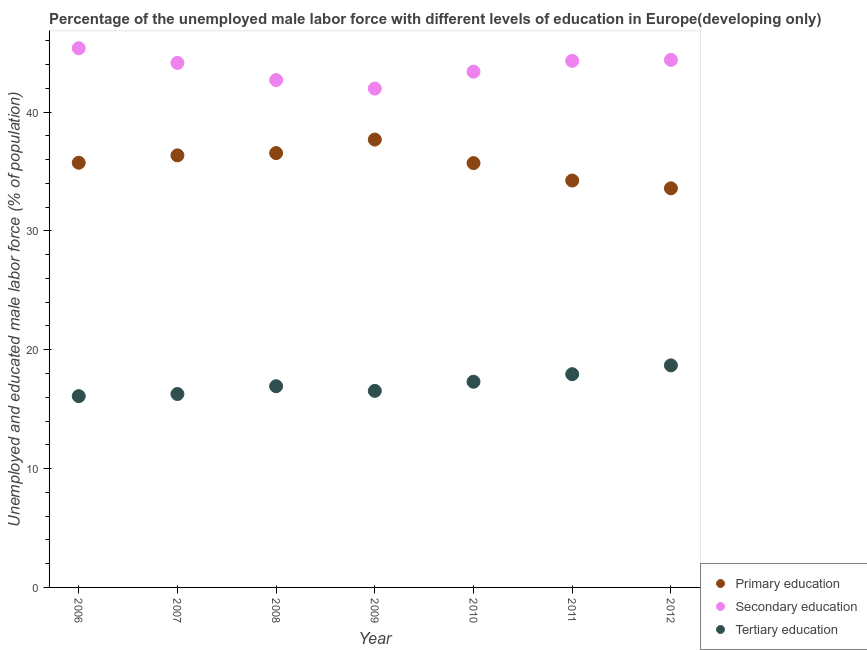Is the number of dotlines equal to the number of legend labels?
Provide a short and direct response. Yes. What is the percentage of male labor force who received primary education in 2007?
Your answer should be very brief. 36.36. Across all years, what is the maximum percentage of male labor force who received primary education?
Your response must be concise. 37.68. Across all years, what is the minimum percentage of male labor force who received secondary education?
Provide a short and direct response. 41.97. What is the total percentage of male labor force who received tertiary education in the graph?
Your answer should be very brief. 119.77. What is the difference between the percentage of male labor force who received primary education in 2011 and that in 2012?
Keep it short and to the point. 0.66. What is the difference between the percentage of male labor force who received tertiary education in 2007 and the percentage of male labor force who received secondary education in 2009?
Offer a very short reply. -25.7. What is the average percentage of male labor force who received secondary education per year?
Your answer should be compact. 43.75. In the year 2009, what is the difference between the percentage of male labor force who received tertiary education and percentage of male labor force who received secondary education?
Your answer should be compact. -25.44. What is the ratio of the percentage of male labor force who received secondary education in 2009 to that in 2010?
Keep it short and to the point. 0.97. What is the difference between the highest and the second highest percentage of male labor force who received secondary education?
Your answer should be compact. 0.98. What is the difference between the highest and the lowest percentage of male labor force who received secondary education?
Offer a terse response. 3.4. Is the percentage of male labor force who received primary education strictly greater than the percentage of male labor force who received tertiary education over the years?
Your answer should be compact. Yes. Are the values on the major ticks of Y-axis written in scientific E-notation?
Make the answer very short. No. Does the graph contain grids?
Keep it short and to the point. No. Where does the legend appear in the graph?
Your answer should be compact. Bottom right. How are the legend labels stacked?
Your answer should be compact. Vertical. What is the title of the graph?
Ensure brevity in your answer.  Percentage of the unemployed male labor force with different levels of education in Europe(developing only). Does "Ages 50+" appear as one of the legend labels in the graph?
Provide a short and direct response. No. What is the label or title of the Y-axis?
Your answer should be compact. Unemployed and educated male labor force (% of population). What is the Unemployed and educated male labor force (% of population) in Primary education in 2006?
Keep it short and to the point. 35.73. What is the Unemployed and educated male labor force (% of population) of Secondary education in 2006?
Offer a terse response. 45.37. What is the Unemployed and educated male labor force (% of population) of Tertiary education in 2006?
Offer a very short reply. 16.1. What is the Unemployed and educated male labor force (% of population) in Primary education in 2007?
Keep it short and to the point. 36.36. What is the Unemployed and educated male labor force (% of population) in Secondary education in 2007?
Your response must be concise. 44.13. What is the Unemployed and educated male labor force (% of population) of Tertiary education in 2007?
Your answer should be compact. 16.27. What is the Unemployed and educated male labor force (% of population) in Primary education in 2008?
Offer a very short reply. 36.55. What is the Unemployed and educated male labor force (% of population) in Secondary education in 2008?
Your answer should be compact. 42.69. What is the Unemployed and educated male labor force (% of population) of Tertiary education in 2008?
Provide a succinct answer. 16.93. What is the Unemployed and educated male labor force (% of population) in Primary education in 2009?
Your response must be concise. 37.68. What is the Unemployed and educated male labor force (% of population) of Secondary education in 2009?
Give a very brief answer. 41.97. What is the Unemployed and educated male labor force (% of population) in Tertiary education in 2009?
Give a very brief answer. 16.54. What is the Unemployed and educated male labor force (% of population) of Primary education in 2010?
Offer a terse response. 35.7. What is the Unemployed and educated male labor force (% of population) of Secondary education in 2010?
Offer a very short reply. 43.39. What is the Unemployed and educated male labor force (% of population) of Tertiary education in 2010?
Provide a succinct answer. 17.31. What is the Unemployed and educated male labor force (% of population) in Primary education in 2011?
Your response must be concise. 34.24. What is the Unemployed and educated male labor force (% of population) of Secondary education in 2011?
Make the answer very short. 44.31. What is the Unemployed and educated male labor force (% of population) of Tertiary education in 2011?
Your response must be concise. 17.94. What is the Unemployed and educated male labor force (% of population) in Primary education in 2012?
Ensure brevity in your answer.  33.58. What is the Unemployed and educated male labor force (% of population) in Secondary education in 2012?
Keep it short and to the point. 44.39. What is the Unemployed and educated male labor force (% of population) in Tertiary education in 2012?
Provide a short and direct response. 18.68. Across all years, what is the maximum Unemployed and educated male labor force (% of population) of Primary education?
Ensure brevity in your answer.  37.68. Across all years, what is the maximum Unemployed and educated male labor force (% of population) of Secondary education?
Make the answer very short. 45.37. Across all years, what is the maximum Unemployed and educated male labor force (% of population) in Tertiary education?
Ensure brevity in your answer.  18.68. Across all years, what is the minimum Unemployed and educated male labor force (% of population) in Primary education?
Your answer should be compact. 33.58. Across all years, what is the minimum Unemployed and educated male labor force (% of population) in Secondary education?
Provide a succinct answer. 41.97. Across all years, what is the minimum Unemployed and educated male labor force (% of population) of Tertiary education?
Offer a terse response. 16.1. What is the total Unemployed and educated male labor force (% of population) in Primary education in the graph?
Your answer should be very brief. 249.84. What is the total Unemployed and educated male labor force (% of population) of Secondary education in the graph?
Give a very brief answer. 306.25. What is the total Unemployed and educated male labor force (% of population) of Tertiary education in the graph?
Your response must be concise. 119.77. What is the difference between the Unemployed and educated male labor force (% of population) of Primary education in 2006 and that in 2007?
Make the answer very short. -0.62. What is the difference between the Unemployed and educated male labor force (% of population) in Secondary education in 2006 and that in 2007?
Your response must be concise. 1.24. What is the difference between the Unemployed and educated male labor force (% of population) in Tertiary education in 2006 and that in 2007?
Offer a terse response. -0.18. What is the difference between the Unemployed and educated male labor force (% of population) of Primary education in 2006 and that in 2008?
Provide a short and direct response. -0.81. What is the difference between the Unemployed and educated male labor force (% of population) in Secondary education in 2006 and that in 2008?
Your answer should be very brief. 2.68. What is the difference between the Unemployed and educated male labor force (% of population) in Tertiary education in 2006 and that in 2008?
Your response must be concise. -0.83. What is the difference between the Unemployed and educated male labor force (% of population) of Primary education in 2006 and that in 2009?
Your answer should be very brief. -1.95. What is the difference between the Unemployed and educated male labor force (% of population) in Secondary education in 2006 and that in 2009?
Ensure brevity in your answer.  3.4. What is the difference between the Unemployed and educated male labor force (% of population) of Tertiary education in 2006 and that in 2009?
Your response must be concise. -0.44. What is the difference between the Unemployed and educated male labor force (% of population) of Primary education in 2006 and that in 2010?
Your response must be concise. 0.03. What is the difference between the Unemployed and educated male labor force (% of population) of Secondary education in 2006 and that in 2010?
Your answer should be compact. 1.97. What is the difference between the Unemployed and educated male labor force (% of population) of Tertiary education in 2006 and that in 2010?
Offer a very short reply. -1.21. What is the difference between the Unemployed and educated male labor force (% of population) in Primary education in 2006 and that in 2011?
Your answer should be very brief. 1.5. What is the difference between the Unemployed and educated male labor force (% of population) in Secondary education in 2006 and that in 2011?
Your answer should be very brief. 1.06. What is the difference between the Unemployed and educated male labor force (% of population) of Tertiary education in 2006 and that in 2011?
Your response must be concise. -1.85. What is the difference between the Unemployed and educated male labor force (% of population) in Primary education in 2006 and that in 2012?
Provide a short and direct response. 2.15. What is the difference between the Unemployed and educated male labor force (% of population) in Secondary education in 2006 and that in 2012?
Your answer should be very brief. 0.98. What is the difference between the Unemployed and educated male labor force (% of population) in Tertiary education in 2006 and that in 2012?
Your answer should be compact. -2.59. What is the difference between the Unemployed and educated male labor force (% of population) in Primary education in 2007 and that in 2008?
Keep it short and to the point. -0.19. What is the difference between the Unemployed and educated male labor force (% of population) in Secondary education in 2007 and that in 2008?
Give a very brief answer. 1.45. What is the difference between the Unemployed and educated male labor force (% of population) in Tertiary education in 2007 and that in 2008?
Your answer should be compact. -0.65. What is the difference between the Unemployed and educated male labor force (% of population) in Primary education in 2007 and that in 2009?
Ensure brevity in your answer.  -1.33. What is the difference between the Unemployed and educated male labor force (% of population) of Secondary education in 2007 and that in 2009?
Provide a short and direct response. 2.16. What is the difference between the Unemployed and educated male labor force (% of population) of Tertiary education in 2007 and that in 2009?
Give a very brief answer. -0.26. What is the difference between the Unemployed and educated male labor force (% of population) of Primary education in 2007 and that in 2010?
Offer a very short reply. 0.65. What is the difference between the Unemployed and educated male labor force (% of population) in Secondary education in 2007 and that in 2010?
Ensure brevity in your answer.  0.74. What is the difference between the Unemployed and educated male labor force (% of population) in Tertiary education in 2007 and that in 2010?
Offer a very short reply. -1.03. What is the difference between the Unemployed and educated male labor force (% of population) of Primary education in 2007 and that in 2011?
Keep it short and to the point. 2.12. What is the difference between the Unemployed and educated male labor force (% of population) of Secondary education in 2007 and that in 2011?
Provide a short and direct response. -0.17. What is the difference between the Unemployed and educated male labor force (% of population) of Tertiary education in 2007 and that in 2011?
Ensure brevity in your answer.  -1.67. What is the difference between the Unemployed and educated male labor force (% of population) in Primary education in 2007 and that in 2012?
Offer a terse response. 2.78. What is the difference between the Unemployed and educated male labor force (% of population) of Secondary education in 2007 and that in 2012?
Keep it short and to the point. -0.26. What is the difference between the Unemployed and educated male labor force (% of population) of Tertiary education in 2007 and that in 2012?
Provide a succinct answer. -2.41. What is the difference between the Unemployed and educated male labor force (% of population) of Primary education in 2008 and that in 2009?
Provide a short and direct response. -1.14. What is the difference between the Unemployed and educated male labor force (% of population) in Secondary education in 2008 and that in 2009?
Your answer should be very brief. 0.71. What is the difference between the Unemployed and educated male labor force (% of population) in Tertiary education in 2008 and that in 2009?
Offer a terse response. 0.39. What is the difference between the Unemployed and educated male labor force (% of population) of Primary education in 2008 and that in 2010?
Your answer should be very brief. 0.84. What is the difference between the Unemployed and educated male labor force (% of population) in Secondary education in 2008 and that in 2010?
Make the answer very short. -0.71. What is the difference between the Unemployed and educated male labor force (% of population) of Tertiary education in 2008 and that in 2010?
Your response must be concise. -0.38. What is the difference between the Unemployed and educated male labor force (% of population) of Primary education in 2008 and that in 2011?
Your response must be concise. 2.31. What is the difference between the Unemployed and educated male labor force (% of population) in Secondary education in 2008 and that in 2011?
Make the answer very short. -1.62. What is the difference between the Unemployed and educated male labor force (% of population) in Tertiary education in 2008 and that in 2011?
Provide a short and direct response. -1.01. What is the difference between the Unemployed and educated male labor force (% of population) in Primary education in 2008 and that in 2012?
Your response must be concise. 2.97. What is the difference between the Unemployed and educated male labor force (% of population) in Secondary education in 2008 and that in 2012?
Give a very brief answer. -1.7. What is the difference between the Unemployed and educated male labor force (% of population) in Tertiary education in 2008 and that in 2012?
Keep it short and to the point. -1.75. What is the difference between the Unemployed and educated male labor force (% of population) in Primary education in 2009 and that in 2010?
Offer a terse response. 1.98. What is the difference between the Unemployed and educated male labor force (% of population) in Secondary education in 2009 and that in 2010?
Your response must be concise. -1.42. What is the difference between the Unemployed and educated male labor force (% of population) in Tertiary education in 2009 and that in 2010?
Keep it short and to the point. -0.77. What is the difference between the Unemployed and educated male labor force (% of population) in Primary education in 2009 and that in 2011?
Provide a short and direct response. 3.45. What is the difference between the Unemployed and educated male labor force (% of population) in Secondary education in 2009 and that in 2011?
Your answer should be compact. -2.33. What is the difference between the Unemployed and educated male labor force (% of population) of Tertiary education in 2009 and that in 2011?
Offer a very short reply. -1.4. What is the difference between the Unemployed and educated male labor force (% of population) of Primary education in 2009 and that in 2012?
Offer a terse response. 4.1. What is the difference between the Unemployed and educated male labor force (% of population) of Secondary education in 2009 and that in 2012?
Your answer should be very brief. -2.42. What is the difference between the Unemployed and educated male labor force (% of population) in Tertiary education in 2009 and that in 2012?
Give a very brief answer. -2.15. What is the difference between the Unemployed and educated male labor force (% of population) of Primary education in 2010 and that in 2011?
Your answer should be very brief. 1.47. What is the difference between the Unemployed and educated male labor force (% of population) of Secondary education in 2010 and that in 2011?
Your answer should be very brief. -0.91. What is the difference between the Unemployed and educated male labor force (% of population) in Tertiary education in 2010 and that in 2011?
Your answer should be very brief. -0.64. What is the difference between the Unemployed and educated male labor force (% of population) of Primary education in 2010 and that in 2012?
Offer a terse response. 2.12. What is the difference between the Unemployed and educated male labor force (% of population) in Secondary education in 2010 and that in 2012?
Offer a terse response. -1. What is the difference between the Unemployed and educated male labor force (% of population) of Tertiary education in 2010 and that in 2012?
Your answer should be very brief. -1.38. What is the difference between the Unemployed and educated male labor force (% of population) in Primary education in 2011 and that in 2012?
Ensure brevity in your answer.  0.66. What is the difference between the Unemployed and educated male labor force (% of population) of Secondary education in 2011 and that in 2012?
Provide a short and direct response. -0.08. What is the difference between the Unemployed and educated male labor force (% of population) of Tertiary education in 2011 and that in 2012?
Your answer should be very brief. -0.74. What is the difference between the Unemployed and educated male labor force (% of population) in Primary education in 2006 and the Unemployed and educated male labor force (% of population) in Secondary education in 2007?
Keep it short and to the point. -8.4. What is the difference between the Unemployed and educated male labor force (% of population) in Primary education in 2006 and the Unemployed and educated male labor force (% of population) in Tertiary education in 2007?
Offer a terse response. 19.46. What is the difference between the Unemployed and educated male labor force (% of population) of Secondary education in 2006 and the Unemployed and educated male labor force (% of population) of Tertiary education in 2007?
Your response must be concise. 29.1. What is the difference between the Unemployed and educated male labor force (% of population) of Primary education in 2006 and the Unemployed and educated male labor force (% of population) of Secondary education in 2008?
Provide a succinct answer. -6.96. What is the difference between the Unemployed and educated male labor force (% of population) in Primary education in 2006 and the Unemployed and educated male labor force (% of population) in Tertiary education in 2008?
Provide a succinct answer. 18.8. What is the difference between the Unemployed and educated male labor force (% of population) in Secondary education in 2006 and the Unemployed and educated male labor force (% of population) in Tertiary education in 2008?
Keep it short and to the point. 28.44. What is the difference between the Unemployed and educated male labor force (% of population) in Primary education in 2006 and the Unemployed and educated male labor force (% of population) in Secondary education in 2009?
Your answer should be compact. -6.24. What is the difference between the Unemployed and educated male labor force (% of population) in Primary education in 2006 and the Unemployed and educated male labor force (% of population) in Tertiary education in 2009?
Ensure brevity in your answer.  19.19. What is the difference between the Unemployed and educated male labor force (% of population) in Secondary education in 2006 and the Unemployed and educated male labor force (% of population) in Tertiary education in 2009?
Your answer should be very brief. 28.83. What is the difference between the Unemployed and educated male labor force (% of population) of Primary education in 2006 and the Unemployed and educated male labor force (% of population) of Secondary education in 2010?
Your response must be concise. -7.66. What is the difference between the Unemployed and educated male labor force (% of population) of Primary education in 2006 and the Unemployed and educated male labor force (% of population) of Tertiary education in 2010?
Ensure brevity in your answer.  18.43. What is the difference between the Unemployed and educated male labor force (% of population) in Secondary education in 2006 and the Unemployed and educated male labor force (% of population) in Tertiary education in 2010?
Provide a short and direct response. 28.06. What is the difference between the Unemployed and educated male labor force (% of population) in Primary education in 2006 and the Unemployed and educated male labor force (% of population) in Secondary education in 2011?
Provide a succinct answer. -8.57. What is the difference between the Unemployed and educated male labor force (% of population) in Primary education in 2006 and the Unemployed and educated male labor force (% of population) in Tertiary education in 2011?
Offer a terse response. 17.79. What is the difference between the Unemployed and educated male labor force (% of population) in Secondary education in 2006 and the Unemployed and educated male labor force (% of population) in Tertiary education in 2011?
Your answer should be very brief. 27.43. What is the difference between the Unemployed and educated male labor force (% of population) of Primary education in 2006 and the Unemployed and educated male labor force (% of population) of Secondary education in 2012?
Make the answer very short. -8.66. What is the difference between the Unemployed and educated male labor force (% of population) in Primary education in 2006 and the Unemployed and educated male labor force (% of population) in Tertiary education in 2012?
Offer a terse response. 17.05. What is the difference between the Unemployed and educated male labor force (% of population) in Secondary education in 2006 and the Unemployed and educated male labor force (% of population) in Tertiary education in 2012?
Provide a succinct answer. 26.69. What is the difference between the Unemployed and educated male labor force (% of population) in Primary education in 2007 and the Unemployed and educated male labor force (% of population) in Secondary education in 2008?
Your answer should be very brief. -6.33. What is the difference between the Unemployed and educated male labor force (% of population) of Primary education in 2007 and the Unemployed and educated male labor force (% of population) of Tertiary education in 2008?
Give a very brief answer. 19.43. What is the difference between the Unemployed and educated male labor force (% of population) in Secondary education in 2007 and the Unemployed and educated male labor force (% of population) in Tertiary education in 2008?
Keep it short and to the point. 27.2. What is the difference between the Unemployed and educated male labor force (% of population) of Primary education in 2007 and the Unemployed and educated male labor force (% of population) of Secondary education in 2009?
Your response must be concise. -5.62. What is the difference between the Unemployed and educated male labor force (% of population) of Primary education in 2007 and the Unemployed and educated male labor force (% of population) of Tertiary education in 2009?
Your response must be concise. 19.82. What is the difference between the Unemployed and educated male labor force (% of population) in Secondary education in 2007 and the Unemployed and educated male labor force (% of population) in Tertiary education in 2009?
Your answer should be compact. 27.6. What is the difference between the Unemployed and educated male labor force (% of population) of Primary education in 2007 and the Unemployed and educated male labor force (% of population) of Secondary education in 2010?
Your response must be concise. -7.04. What is the difference between the Unemployed and educated male labor force (% of population) of Primary education in 2007 and the Unemployed and educated male labor force (% of population) of Tertiary education in 2010?
Ensure brevity in your answer.  19.05. What is the difference between the Unemployed and educated male labor force (% of population) in Secondary education in 2007 and the Unemployed and educated male labor force (% of population) in Tertiary education in 2010?
Provide a short and direct response. 26.83. What is the difference between the Unemployed and educated male labor force (% of population) in Primary education in 2007 and the Unemployed and educated male labor force (% of population) in Secondary education in 2011?
Provide a succinct answer. -7.95. What is the difference between the Unemployed and educated male labor force (% of population) of Primary education in 2007 and the Unemployed and educated male labor force (% of population) of Tertiary education in 2011?
Give a very brief answer. 18.41. What is the difference between the Unemployed and educated male labor force (% of population) of Secondary education in 2007 and the Unemployed and educated male labor force (% of population) of Tertiary education in 2011?
Offer a terse response. 26.19. What is the difference between the Unemployed and educated male labor force (% of population) of Primary education in 2007 and the Unemployed and educated male labor force (% of population) of Secondary education in 2012?
Provide a succinct answer. -8.03. What is the difference between the Unemployed and educated male labor force (% of population) in Primary education in 2007 and the Unemployed and educated male labor force (% of population) in Tertiary education in 2012?
Ensure brevity in your answer.  17.67. What is the difference between the Unemployed and educated male labor force (% of population) in Secondary education in 2007 and the Unemployed and educated male labor force (% of population) in Tertiary education in 2012?
Offer a very short reply. 25.45. What is the difference between the Unemployed and educated male labor force (% of population) of Primary education in 2008 and the Unemployed and educated male labor force (% of population) of Secondary education in 2009?
Make the answer very short. -5.43. What is the difference between the Unemployed and educated male labor force (% of population) of Primary education in 2008 and the Unemployed and educated male labor force (% of population) of Tertiary education in 2009?
Offer a terse response. 20.01. What is the difference between the Unemployed and educated male labor force (% of population) of Secondary education in 2008 and the Unemployed and educated male labor force (% of population) of Tertiary education in 2009?
Ensure brevity in your answer.  26.15. What is the difference between the Unemployed and educated male labor force (% of population) of Primary education in 2008 and the Unemployed and educated male labor force (% of population) of Secondary education in 2010?
Offer a very short reply. -6.85. What is the difference between the Unemployed and educated male labor force (% of population) of Primary education in 2008 and the Unemployed and educated male labor force (% of population) of Tertiary education in 2010?
Your answer should be compact. 19.24. What is the difference between the Unemployed and educated male labor force (% of population) in Secondary education in 2008 and the Unemployed and educated male labor force (% of population) in Tertiary education in 2010?
Make the answer very short. 25.38. What is the difference between the Unemployed and educated male labor force (% of population) of Primary education in 2008 and the Unemployed and educated male labor force (% of population) of Secondary education in 2011?
Your answer should be compact. -7.76. What is the difference between the Unemployed and educated male labor force (% of population) in Primary education in 2008 and the Unemployed and educated male labor force (% of population) in Tertiary education in 2011?
Your answer should be compact. 18.6. What is the difference between the Unemployed and educated male labor force (% of population) in Secondary education in 2008 and the Unemployed and educated male labor force (% of population) in Tertiary education in 2011?
Provide a succinct answer. 24.75. What is the difference between the Unemployed and educated male labor force (% of population) of Primary education in 2008 and the Unemployed and educated male labor force (% of population) of Secondary education in 2012?
Offer a terse response. -7.84. What is the difference between the Unemployed and educated male labor force (% of population) in Primary education in 2008 and the Unemployed and educated male labor force (% of population) in Tertiary education in 2012?
Keep it short and to the point. 17.86. What is the difference between the Unemployed and educated male labor force (% of population) of Secondary education in 2008 and the Unemployed and educated male labor force (% of population) of Tertiary education in 2012?
Your response must be concise. 24. What is the difference between the Unemployed and educated male labor force (% of population) in Primary education in 2009 and the Unemployed and educated male labor force (% of population) in Secondary education in 2010?
Make the answer very short. -5.71. What is the difference between the Unemployed and educated male labor force (% of population) of Primary education in 2009 and the Unemployed and educated male labor force (% of population) of Tertiary education in 2010?
Your answer should be very brief. 20.38. What is the difference between the Unemployed and educated male labor force (% of population) of Secondary education in 2009 and the Unemployed and educated male labor force (% of population) of Tertiary education in 2010?
Provide a short and direct response. 24.67. What is the difference between the Unemployed and educated male labor force (% of population) in Primary education in 2009 and the Unemployed and educated male labor force (% of population) in Secondary education in 2011?
Ensure brevity in your answer.  -6.62. What is the difference between the Unemployed and educated male labor force (% of population) of Primary education in 2009 and the Unemployed and educated male labor force (% of population) of Tertiary education in 2011?
Offer a very short reply. 19.74. What is the difference between the Unemployed and educated male labor force (% of population) of Secondary education in 2009 and the Unemployed and educated male labor force (% of population) of Tertiary education in 2011?
Offer a terse response. 24.03. What is the difference between the Unemployed and educated male labor force (% of population) of Primary education in 2009 and the Unemployed and educated male labor force (% of population) of Secondary education in 2012?
Offer a terse response. -6.71. What is the difference between the Unemployed and educated male labor force (% of population) of Primary education in 2009 and the Unemployed and educated male labor force (% of population) of Tertiary education in 2012?
Your answer should be compact. 19. What is the difference between the Unemployed and educated male labor force (% of population) of Secondary education in 2009 and the Unemployed and educated male labor force (% of population) of Tertiary education in 2012?
Keep it short and to the point. 23.29. What is the difference between the Unemployed and educated male labor force (% of population) of Primary education in 2010 and the Unemployed and educated male labor force (% of population) of Secondary education in 2011?
Keep it short and to the point. -8.6. What is the difference between the Unemployed and educated male labor force (% of population) in Primary education in 2010 and the Unemployed and educated male labor force (% of population) in Tertiary education in 2011?
Give a very brief answer. 17.76. What is the difference between the Unemployed and educated male labor force (% of population) of Secondary education in 2010 and the Unemployed and educated male labor force (% of population) of Tertiary education in 2011?
Your response must be concise. 25.45. What is the difference between the Unemployed and educated male labor force (% of population) of Primary education in 2010 and the Unemployed and educated male labor force (% of population) of Secondary education in 2012?
Give a very brief answer. -8.69. What is the difference between the Unemployed and educated male labor force (% of population) of Primary education in 2010 and the Unemployed and educated male labor force (% of population) of Tertiary education in 2012?
Give a very brief answer. 17.02. What is the difference between the Unemployed and educated male labor force (% of population) in Secondary education in 2010 and the Unemployed and educated male labor force (% of population) in Tertiary education in 2012?
Make the answer very short. 24.71. What is the difference between the Unemployed and educated male labor force (% of population) of Primary education in 2011 and the Unemployed and educated male labor force (% of population) of Secondary education in 2012?
Offer a terse response. -10.15. What is the difference between the Unemployed and educated male labor force (% of population) in Primary education in 2011 and the Unemployed and educated male labor force (% of population) in Tertiary education in 2012?
Offer a terse response. 15.55. What is the difference between the Unemployed and educated male labor force (% of population) of Secondary education in 2011 and the Unemployed and educated male labor force (% of population) of Tertiary education in 2012?
Ensure brevity in your answer.  25.62. What is the average Unemployed and educated male labor force (% of population) of Primary education per year?
Your response must be concise. 35.69. What is the average Unemployed and educated male labor force (% of population) in Secondary education per year?
Keep it short and to the point. 43.75. What is the average Unemployed and educated male labor force (% of population) in Tertiary education per year?
Your response must be concise. 17.11. In the year 2006, what is the difference between the Unemployed and educated male labor force (% of population) in Primary education and Unemployed and educated male labor force (% of population) in Secondary education?
Your response must be concise. -9.64. In the year 2006, what is the difference between the Unemployed and educated male labor force (% of population) in Primary education and Unemployed and educated male labor force (% of population) in Tertiary education?
Your response must be concise. 19.64. In the year 2006, what is the difference between the Unemployed and educated male labor force (% of population) in Secondary education and Unemployed and educated male labor force (% of population) in Tertiary education?
Offer a very short reply. 29.27. In the year 2007, what is the difference between the Unemployed and educated male labor force (% of population) in Primary education and Unemployed and educated male labor force (% of population) in Secondary education?
Provide a short and direct response. -7.78. In the year 2007, what is the difference between the Unemployed and educated male labor force (% of population) of Primary education and Unemployed and educated male labor force (% of population) of Tertiary education?
Provide a succinct answer. 20.08. In the year 2007, what is the difference between the Unemployed and educated male labor force (% of population) of Secondary education and Unemployed and educated male labor force (% of population) of Tertiary education?
Ensure brevity in your answer.  27.86. In the year 2008, what is the difference between the Unemployed and educated male labor force (% of population) in Primary education and Unemployed and educated male labor force (% of population) in Secondary education?
Your response must be concise. -6.14. In the year 2008, what is the difference between the Unemployed and educated male labor force (% of population) of Primary education and Unemployed and educated male labor force (% of population) of Tertiary education?
Keep it short and to the point. 19.62. In the year 2008, what is the difference between the Unemployed and educated male labor force (% of population) of Secondary education and Unemployed and educated male labor force (% of population) of Tertiary education?
Offer a terse response. 25.76. In the year 2009, what is the difference between the Unemployed and educated male labor force (% of population) in Primary education and Unemployed and educated male labor force (% of population) in Secondary education?
Your answer should be very brief. -4.29. In the year 2009, what is the difference between the Unemployed and educated male labor force (% of population) in Primary education and Unemployed and educated male labor force (% of population) in Tertiary education?
Offer a very short reply. 21.15. In the year 2009, what is the difference between the Unemployed and educated male labor force (% of population) of Secondary education and Unemployed and educated male labor force (% of population) of Tertiary education?
Give a very brief answer. 25.44. In the year 2010, what is the difference between the Unemployed and educated male labor force (% of population) in Primary education and Unemployed and educated male labor force (% of population) in Secondary education?
Offer a very short reply. -7.69. In the year 2010, what is the difference between the Unemployed and educated male labor force (% of population) in Primary education and Unemployed and educated male labor force (% of population) in Tertiary education?
Keep it short and to the point. 18.4. In the year 2010, what is the difference between the Unemployed and educated male labor force (% of population) of Secondary education and Unemployed and educated male labor force (% of population) of Tertiary education?
Provide a short and direct response. 26.09. In the year 2011, what is the difference between the Unemployed and educated male labor force (% of population) in Primary education and Unemployed and educated male labor force (% of population) in Secondary education?
Your answer should be compact. -10.07. In the year 2011, what is the difference between the Unemployed and educated male labor force (% of population) in Primary education and Unemployed and educated male labor force (% of population) in Tertiary education?
Provide a short and direct response. 16.29. In the year 2011, what is the difference between the Unemployed and educated male labor force (% of population) in Secondary education and Unemployed and educated male labor force (% of population) in Tertiary education?
Your answer should be compact. 26.36. In the year 2012, what is the difference between the Unemployed and educated male labor force (% of population) of Primary education and Unemployed and educated male labor force (% of population) of Secondary education?
Your answer should be very brief. -10.81. In the year 2012, what is the difference between the Unemployed and educated male labor force (% of population) in Primary education and Unemployed and educated male labor force (% of population) in Tertiary education?
Your response must be concise. 14.9. In the year 2012, what is the difference between the Unemployed and educated male labor force (% of population) of Secondary education and Unemployed and educated male labor force (% of population) of Tertiary education?
Your answer should be very brief. 25.71. What is the ratio of the Unemployed and educated male labor force (% of population) in Primary education in 2006 to that in 2007?
Keep it short and to the point. 0.98. What is the ratio of the Unemployed and educated male labor force (% of population) in Secondary education in 2006 to that in 2007?
Give a very brief answer. 1.03. What is the ratio of the Unemployed and educated male labor force (% of population) of Tertiary education in 2006 to that in 2007?
Offer a very short reply. 0.99. What is the ratio of the Unemployed and educated male labor force (% of population) in Primary education in 2006 to that in 2008?
Your response must be concise. 0.98. What is the ratio of the Unemployed and educated male labor force (% of population) in Secondary education in 2006 to that in 2008?
Offer a very short reply. 1.06. What is the ratio of the Unemployed and educated male labor force (% of population) of Tertiary education in 2006 to that in 2008?
Offer a terse response. 0.95. What is the ratio of the Unemployed and educated male labor force (% of population) in Primary education in 2006 to that in 2009?
Your response must be concise. 0.95. What is the ratio of the Unemployed and educated male labor force (% of population) of Secondary education in 2006 to that in 2009?
Ensure brevity in your answer.  1.08. What is the ratio of the Unemployed and educated male labor force (% of population) of Tertiary education in 2006 to that in 2009?
Ensure brevity in your answer.  0.97. What is the ratio of the Unemployed and educated male labor force (% of population) in Secondary education in 2006 to that in 2010?
Provide a succinct answer. 1.05. What is the ratio of the Unemployed and educated male labor force (% of population) in Tertiary education in 2006 to that in 2010?
Your response must be concise. 0.93. What is the ratio of the Unemployed and educated male labor force (% of population) in Primary education in 2006 to that in 2011?
Provide a short and direct response. 1.04. What is the ratio of the Unemployed and educated male labor force (% of population) of Tertiary education in 2006 to that in 2011?
Ensure brevity in your answer.  0.9. What is the ratio of the Unemployed and educated male labor force (% of population) of Primary education in 2006 to that in 2012?
Ensure brevity in your answer.  1.06. What is the ratio of the Unemployed and educated male labor force (% of population) in Secondary education in 2006 to that in 2012?
Make the answer very short. 1.02. What is the ratio of the Unemployed and educated male labor force (% of population) of Tertiary education in 2006 to that in 2012?
Your response must be concise. 0.86. What is the ratio of the Unemployed and educated male labor force (% of population) of Secondary education in 2007 to that in 2008?
Keep it short and to the point. 1.03. What is the ratio of the Unemployed and educated male labor force (% of population) in Tertiary education in 2007 to that in 2008?
Make the answer very short. 0.96. What is the ratio of the Unemployed and educated male labor force (% of population) of Primary education in 2007 to that in 2009?
Offer a very short reply. 0.96. What is the ratio of the Unemployed and educated male labor force (% of population) in Secondary education in 2007 to that in 2009?
Keep it short and to the point. 1.05. What is the ratio of the Unemployed and educated male labor force (% of population) of Tertiary education in 2007 to that in 2009?
Provide a succinct answer. 0.98. What is the ratio of the Unemployed and educated male labor force (% of population) in Primary education in 2007 to that in 2010?
Ensure brevity in your answer.  1.02. What is the ratio of the Unemployed and educated male labor force (% of population) of Secondary education in 2007 to that in 2010?
Offer a very short reply. 1.02. What is the ratio of the Unemployed and educated male labor force (% of population) of Tertiary education in 2007 to that in 2010?
Ensure brevity in your answer.  0.94. What is the ratio of the Unemployed and educated male labor force (% of population) of Primary education in 2007 to that in 2011?
Keep it short and to the point. 1.06. What is the ratio of the Unemployed and educated male labor force (% of population) of Tertiary education in 2007 to that in 2011?
Ensure brevity in your answer.  0.91. What is the ratio of the Unemployed and educated male labor force (% of population) of Primary education in 2007 to that in 2012?
Make the answer very short. 1.08. What is the ratio of the Unemployed and educated male labor force (% of population) in Secondary education in 2007 to that in 2012?
Ensure brevity in your answer.  0.99. What is the ratio of the Unemployed and educated male labor force (% of population) in Tertiary education in 2007 to that in 2012?
Your answer should be compact. 0.87. What is the ratio of the Unemployed and educated male labor force (% of population) of Primary education in 2008 to that in 2009?
Offer a very short reply. 0.97. What is the ratio of the Unemployed and educated male labor force (% of population) of Tertiary education in 2008 to that in 2009?
Provide a short and direct response. 1.02. What is the ratio of the Unemployed and educated male labor force (% of population) in Primary education in 2008 to that in 2010?
Provide a short and direct response. 1.02. What is the ratio of the Unemployed and educated male labor force (% of population) of Secondary education in 2008 to that in 2010?
Offer a terse response. 0.98. What is the ratio of the Unemployed and educated male labor force (% of population) of Tertiary education in 2008 to that in 2010?
Your response must be concise. 0.98. What is the ratio of the Unemployed and educated male labor force (% of population) in Primary education in 2008 to that in 2011?
Give a very brief answer. 1.07. What is the ratio of the Unemployed and educated male labor force (% of population) of Secondary education in 2008 to that in 2011?
Give a very brief answer. 0.96. What is the ratio of the Unemployed and educated male labor force (% of population) in Tertiary education in 2008 to that in 2011?
Keep it short and to the point. 0.94. What is the ratio of the Unemployed and educated male labor force (% of population) of Primary education in 2008 to that in 2012?
Your answer should be compact. 1.09. What is the ratio of the Unemployed and educated male labor force (% of population) in Secondary education in 2008 to that in 2012?
Provide a short and direct response. 0.96. What is the ratio of the Unemployed and educated male labor force (% of population) in Tertiary education in 2008 to that in 2012?
Keep it short and to the point. 0.91. What is the ratio of the Unemployed and educated male labor force (% of population) of Primary education in 2009 to that in 2010?
Your answer should be compact. 1.06. What is the ratio of the Unemployed and educated male labor force (% of population) in Secondary education in 2009 to that in 2010?
Your response must be concise. 0.97. What is the ratio of the Unemployed and educated male labor force (% of population) in Tertiary education in 2009 to that in 2010?
Offer a very short reply. 0.96. What is the ratio of the Unemployed and educated male labor force (% of population) of Primary education in 2009 to that in 2011?
Your response must be concise. 1.1. What is the ratio of the Unemployed and educated male labor force (% of population) in Secondary education in 2009 to that in 2011?
Provide a succinct answer. 0.95. What is the ratio of the Unemployed and educated male labor force (% of population) of Tertiary education in 2009 to that in 2011?
Ensure brevity in your answer.  0.92. What is the ratio of the Unemployed and educated male labor force (% of population) in Primary education in 2009 to that in 2012?
Your response must be concise. 1.12. What is the ratio of the Unemployed and educated male labor force (% of population) in Secondary education in 2009 to that in 2012?
Your answer should be very brief. 0.95. What is the ratio of the Unemployed and educated male labor force (% of population) of Tertiary education in 2009 to that in 2012?
Give a very brief answer. 0.89. What is the ratio of the Unemployed and educated male labor force (% of population) of Primary education in 2010 to that in 2011?
Your answer should be compact. 1.04. What is the ratio of the Unemployed and educated male labor force (% of population) in Secondary education in 2010 to that in 2011?
Offer a very short reply. 0.98. What is the ratio of the Unemployed and educated male labor force (% of population) in Tertiary education in 2010 to that in 2011?
Keep it short and to the point. 0.96. What is the ratio of the Unemployed and educated male labor force (% of population) in Primary education in 2010 to that in 2012?
Your answer should be compact. 1.06. What is the ratio of the Unemployed and educated male labor force (% of population) of Secondary education in 2010 to that in 2012?
Your answer should be very brief. 0.98. What is the ratio of the Unemployed and educated male labor force (% of population) in Tertiary education in 2010 to that in 2012?
Ensure brevity in your answer.  0.93. What is the ratio of the Unemployed and educated male labor force (% of population) of Primary education in 2011 to that in 2012?
Your answer should be compact. 1.02. What is the ratio of the Unemployed and educated male labor force (% of population) of Tertiary education in 2011 to that in 2012?
Provide a succinct answer. 0.96. What is the difference between the highest and the second highest Unemployed and educated male labor force (% of population) of Primary education?
Offer a terse response. 1.14. What is the difference between the highest and the second highest Unemployed and educated male labor force (% of population) of Secondary education?
Offer a terse response. 0.98. What is the difference between the highest and the second highest Unemployed and educated male labor force (% of population) of Tertiary education?
Keep it short and to the point. 0.74. What is the difference between the highest and the lowest Unemployed and educated male labor force (% of population) of Primary education?
Make the answer very short. 4.1. What is the difference between the highest and the lowest Unemployed and educated male labor force (% of population) of Secondary education?
Keep it short and to the point. 3.4. What is the difference between the highest and the lowest Unemployed and educated male labor force (% of population) in Tertiary education?
Give a very brief answer. 2.59. 